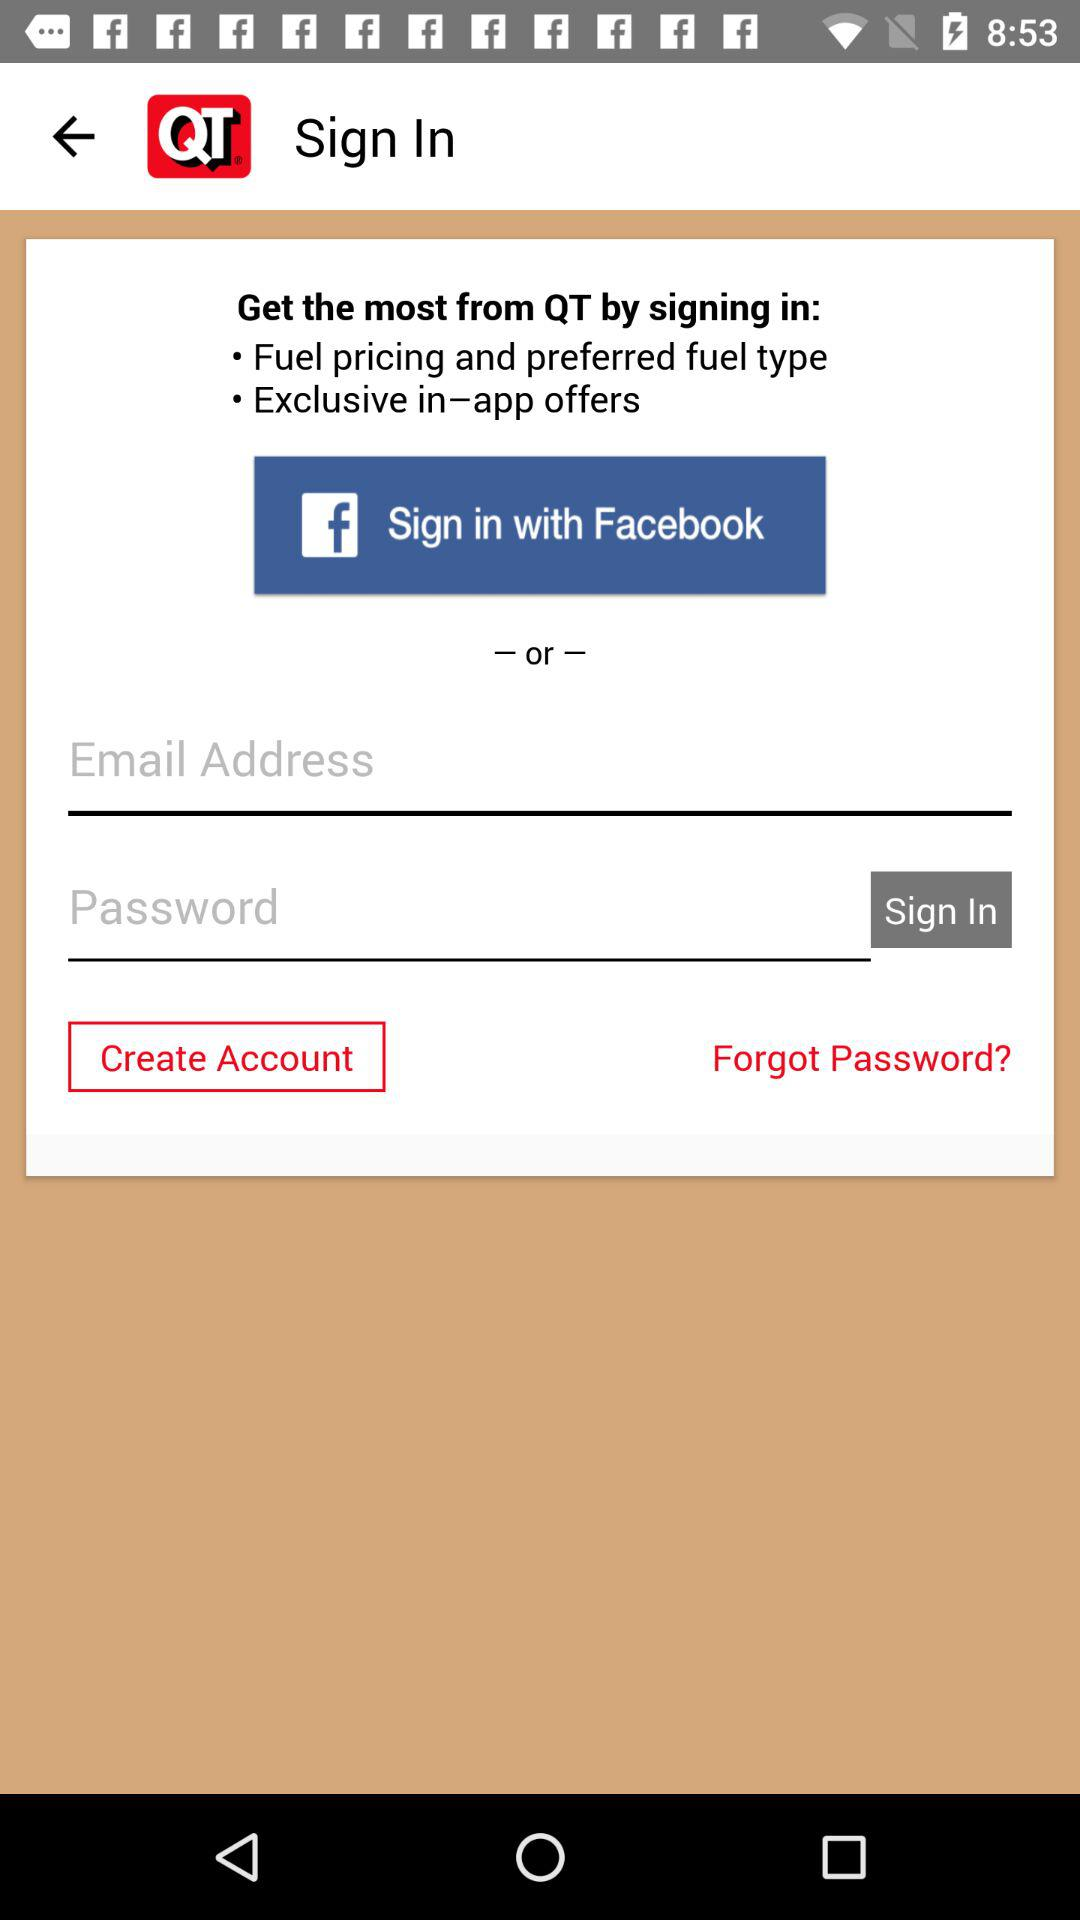How many input fields are there for signing in?
Answer the question using a single word or phrase. 2 